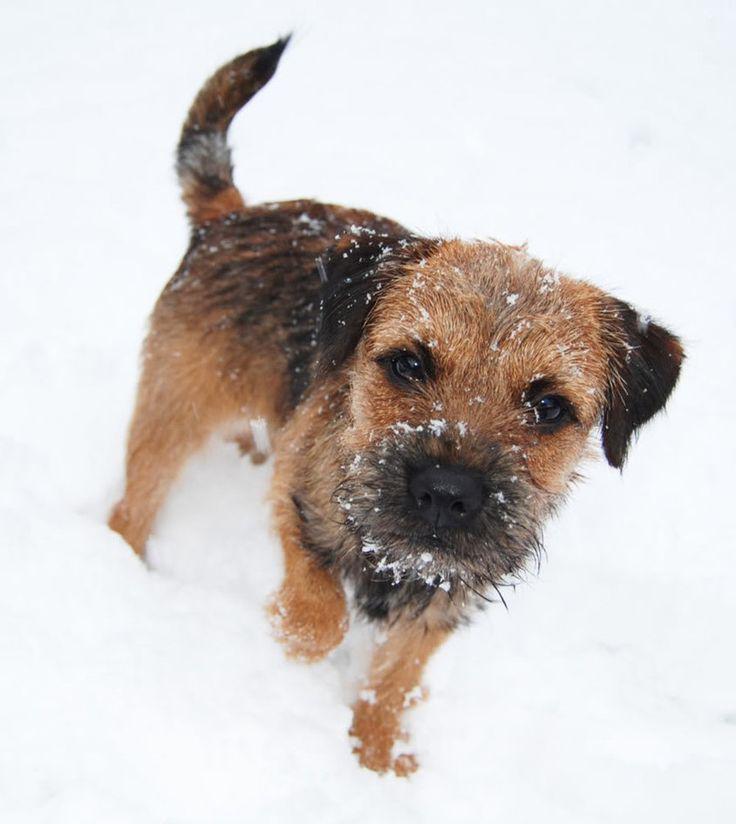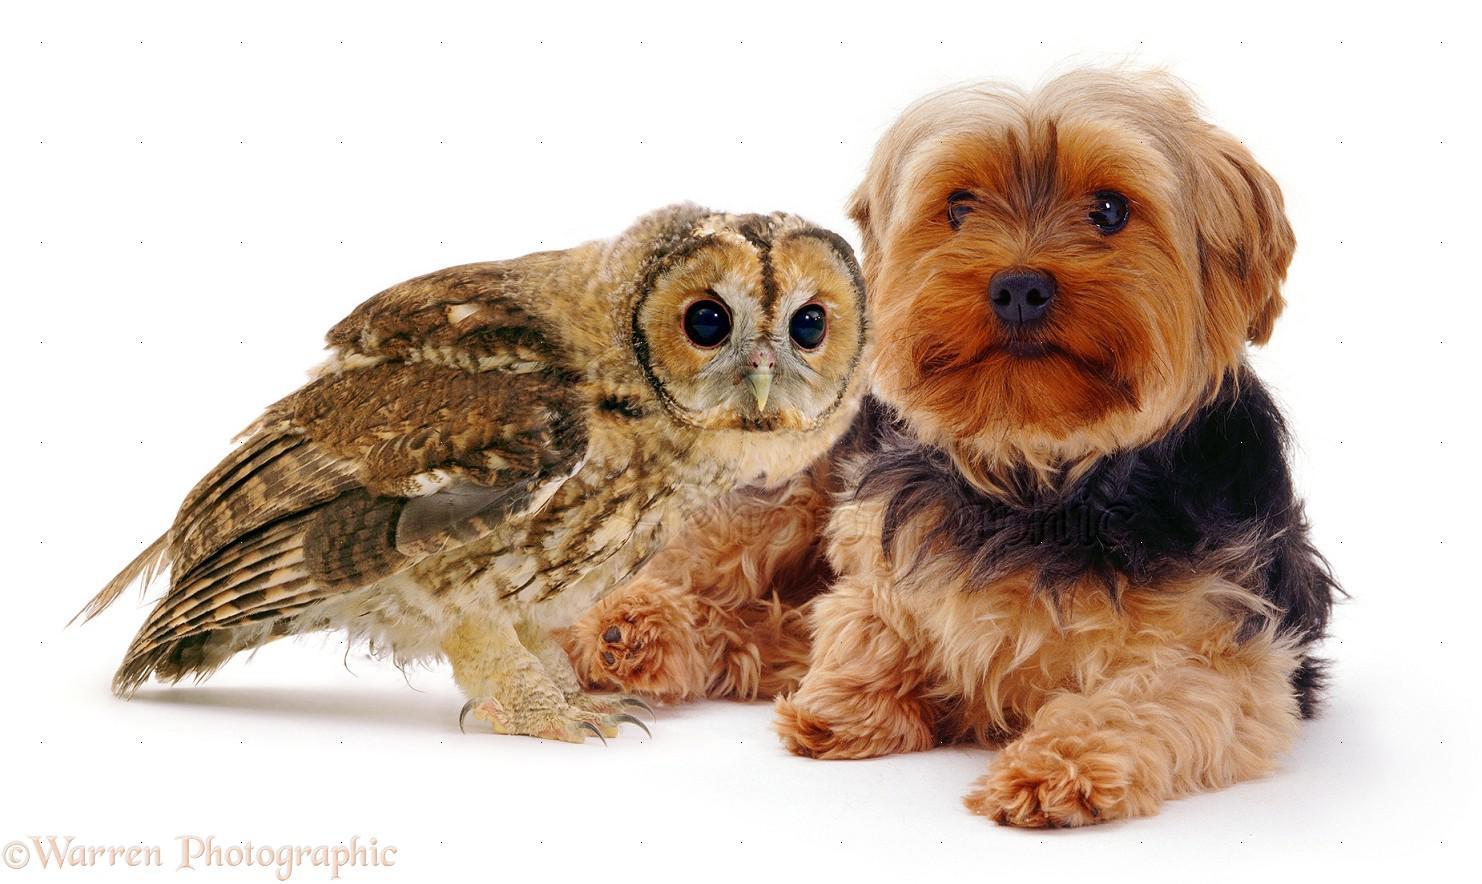The first image is the image on the left, the second image is the image on the right. Assess this claim about the two images: "A black and tan dog has snow on its face.". Correct or not? Answer yes or no. Yes. 